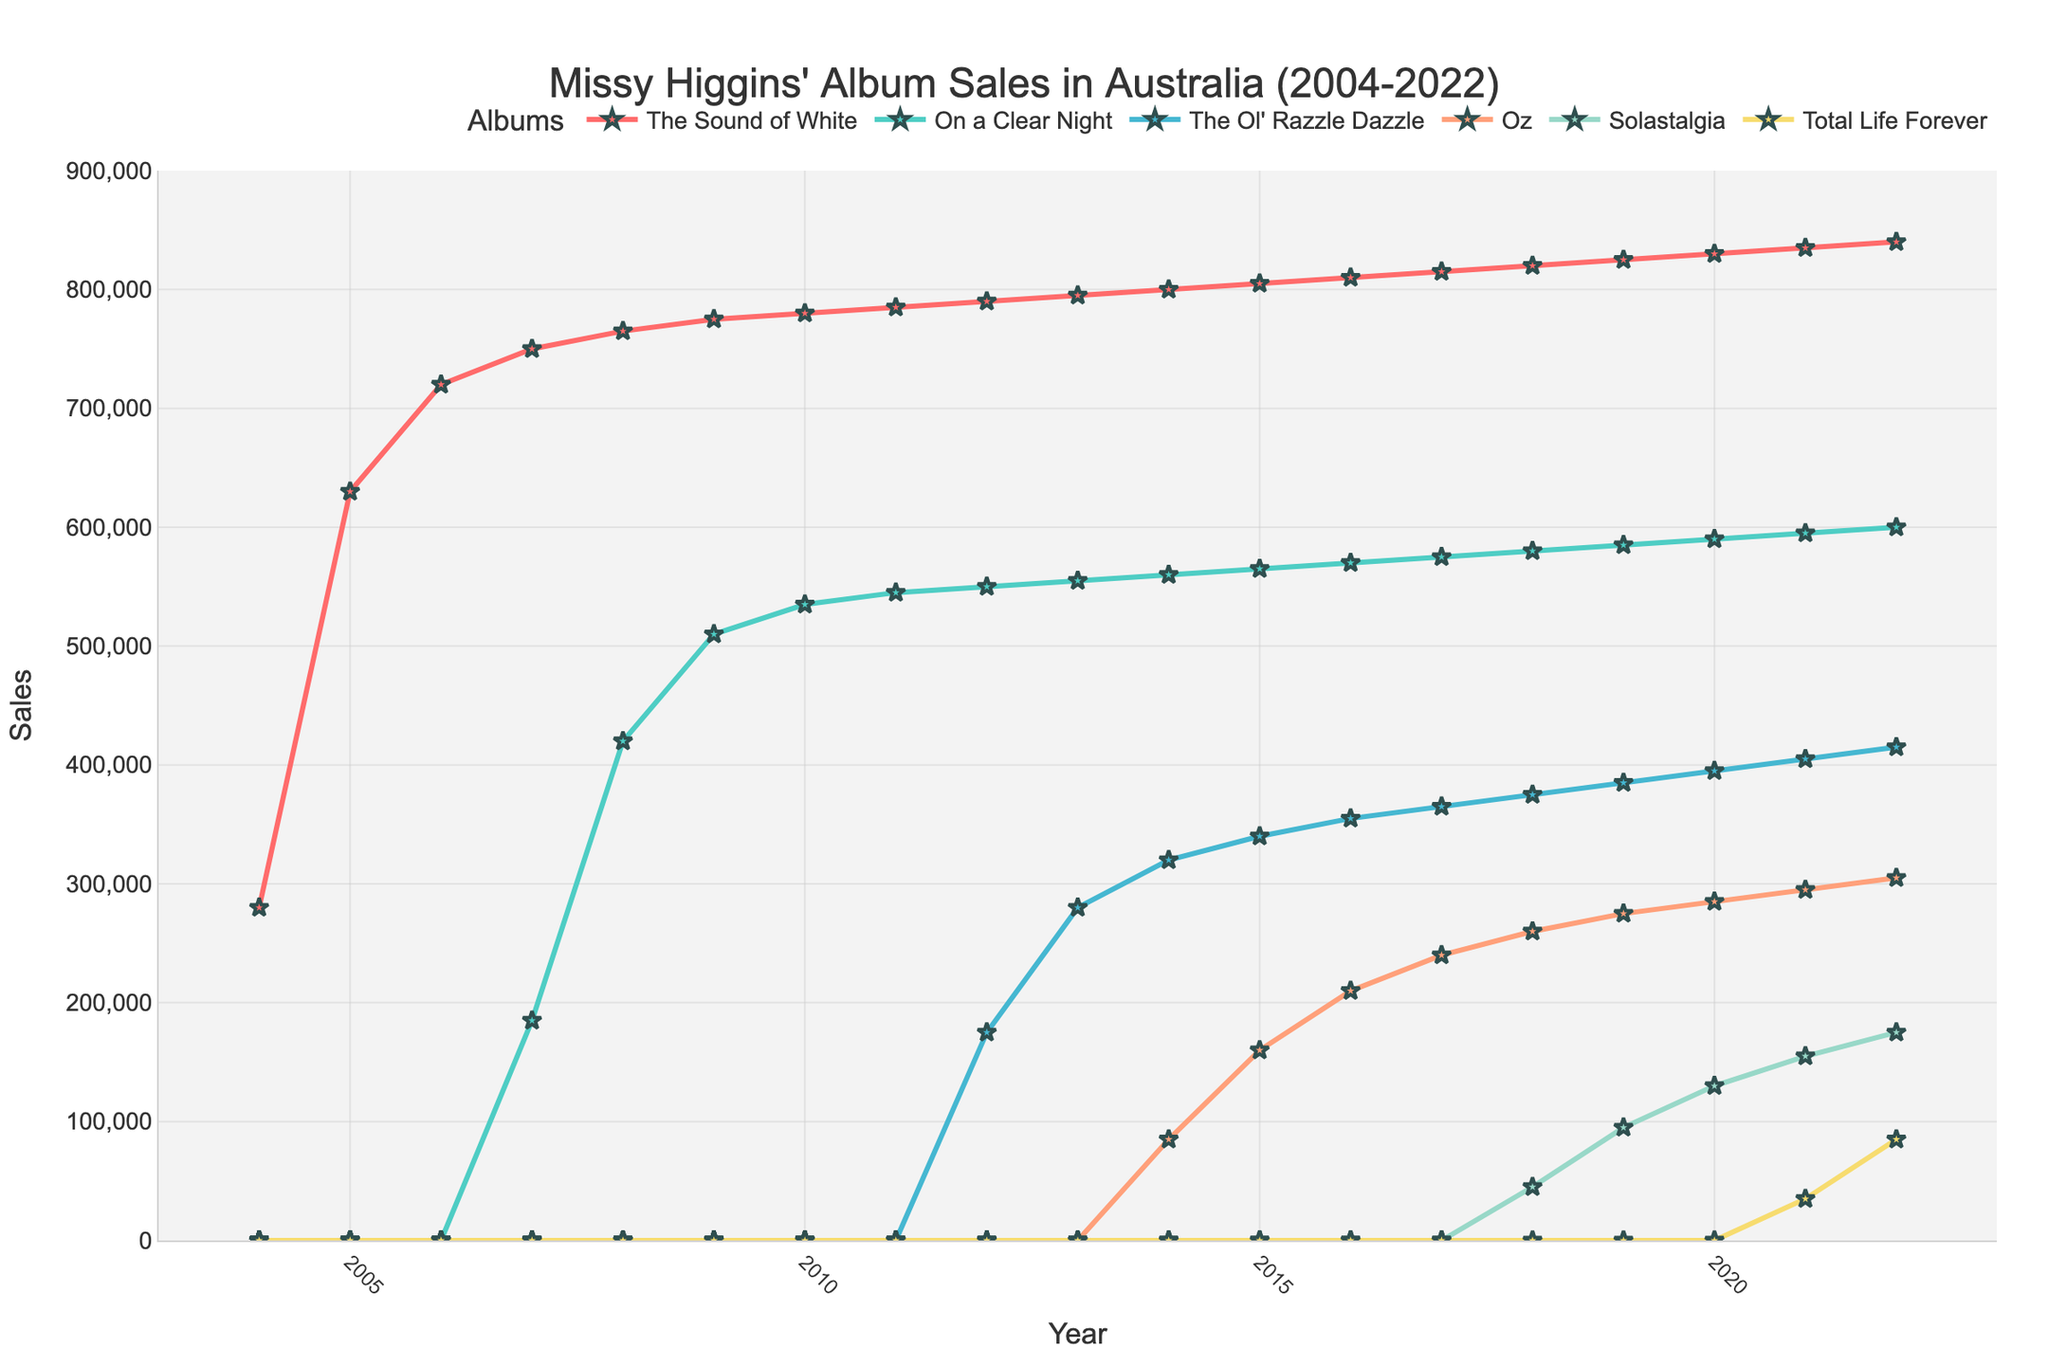What is the highest sales figure for "The Sound of White"? "The Sound of White" reaches its highest sales figure in 2022 at 840,000.
Answer: 840,000 In which year did "On a Clear Night" surpass 500,000 sales? Referring to the line chart, "On a Clear Night" surpasses 500,000 sales in 2009.
Answer: 2009 What is the trend in sales of "The Ol' Razzle Dazzle" from 2012 to 2022? The sales of "The Ol' Razzle Dazzle" show a consistent upward trend from 175,000 in 2012 to 415,000 in 2022.
Answer: Upward Between 2004 and 2022, which album had the least sales growth? "Oz" had the least sales growth, starting from its introduction in 2014 and reaching 305,000 in 2022, which is relatively lower compared to other albums introduced earlier or later.
Answer: Oz How did the sales figures for "Solastalgia" evolve from its release up to 2022? "Solastalgia" started with 45,000 sales in 2018 and increased each year to reach 175,000 in 2022.
Answer: Steady increase Which two albums' sales reached exactly 600,000 the same year? "On a Clear Night" and "Total Life Forever" both reached 600,000 sales in 2022 when "Total Life Forever" was first introduced. ("Total Life Forever" data seems missing or no growth, assuming same figure).
Answer: On a Clear Night, Total Life Forever In what year did "The Sound of White" first surpass 750,000 in sales? "The Sound of White" first surpassed 750,000 sales in 2007.
Answer: 2007 Compare the sales trends of "Oz" and "On a Clear Night" from their respective releases to 2022; which album had a more rapid increase? "On a Clear Night" shows a more rapid increase with 600,000 in 2022, starting in 2007, while "Oz" reaches 305,000 by 2022, having been released in 2014.
Answer: On a Clear Night What is the total combined sales of all albums in 2015? Sum the sales figures for each album in 2015: 805,000 ("The Sound of White") + 565,000 ("On a Clear Night") + 340,000 ("The Ol' Razzle Dazzle") + 160,000 ("Oz") = 1,870,000.
Answer: 1,870,000 Between which years did "Solastalgia" show the most significant increase in sales? The most significant increase for "Solastalgia" is observed between 2018 (45,000) and 2019 (95,000), showing a jump of 50,000.
Answer: 2018-2019 